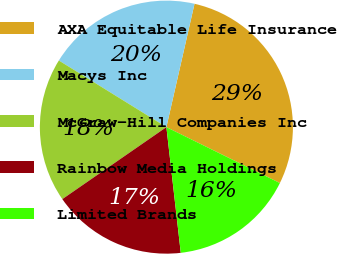Convert chart. <chart><loc_0><loc_0><loc_500><loc_500><pie_chart><fcel>AXA Equitable Life Insurance<fcel>Macys Inc<fcel>McGraw-Hill Companies Inc<fcel>Rainbow Media Holdings<fcel>Limited Brands<nl><fcel>28.72%<fcel>19.74%<fcel>18.46%<fcel>17.18%<fcel>15.9%<nl></chart> 